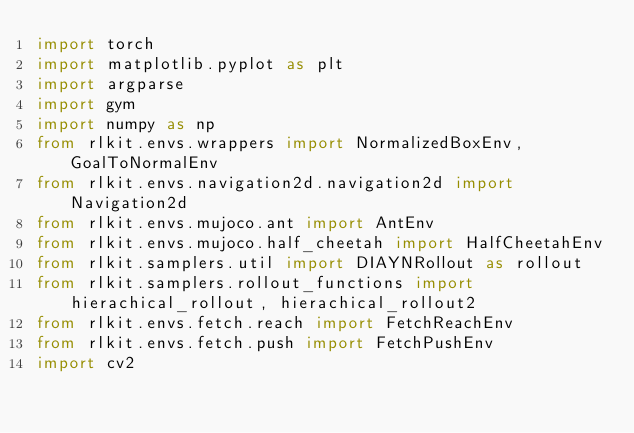Convert code to text. <code><loc_0><loc_0><loc_500><loc_500><_Python_>import torch
import matplotlib.pyplot as plt
import argparse
import gym
import numpy as np
from rlkit.envs.wrappers import NormalizedBoxEnv, GoalToNormalEnv
from rlkit.envs.navigation2d.navigation2d import Navigation2d
from rlkit.envs.mujoco.ant import AntEnv
from rlkit.envs.mujoco.half_cheetah import HalfCheetahEnv
from rlkit.samplers.util import DIAYNRollout as rollout
from rlkit.samplers.rollout_functions import hierachical_rollout, hierachical_rollout2
from rlkit.envs.fetch.reach import FetchReachEnv
from rlkit.envs.fetch.push import FetchPushEnv
import cv2

</code> 